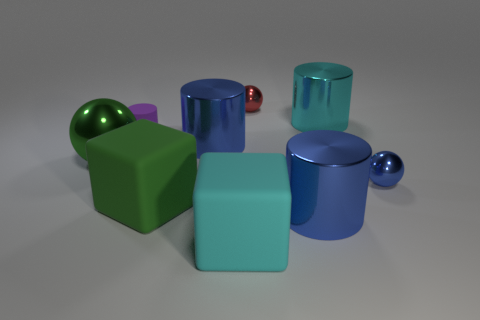What is the shape of the tiny blue shiny object?
Your response must be concise. Sphere. Is the number of rubber cubes on the left side of the purple thing the same as the number of tiny red shiny balls?
Your answer should be very brief. No. There is a matte thing that is the same color as the large metal sphere; what size is it?
Provide a short and direct response. Large. Are there any purple things made of the same material as the large green cube?
Your response must be concise. Yes. There is a metallic object that is right of the big cyan shiny object; does it have the same shape as the green thing that is on the right side of the purple cylinder?
Make the answer very short. No. Are any shiny cylinders visible?
Your response must be concise. Yes. There is a ball that is the same size as the green block; what is its color?
Offer a terse response. Green. What number of other big objects are the same shape as the large cyan matte thing?
Offer a very short reply. 1. Does the large blue cylinder behind the blue metal ball have the same material as the tiny purple cylinder?
Your response must be concise. No. What number of cylinders are either cyan matte objects or red shiny things?
Ensure brevity in your answer.  0. 